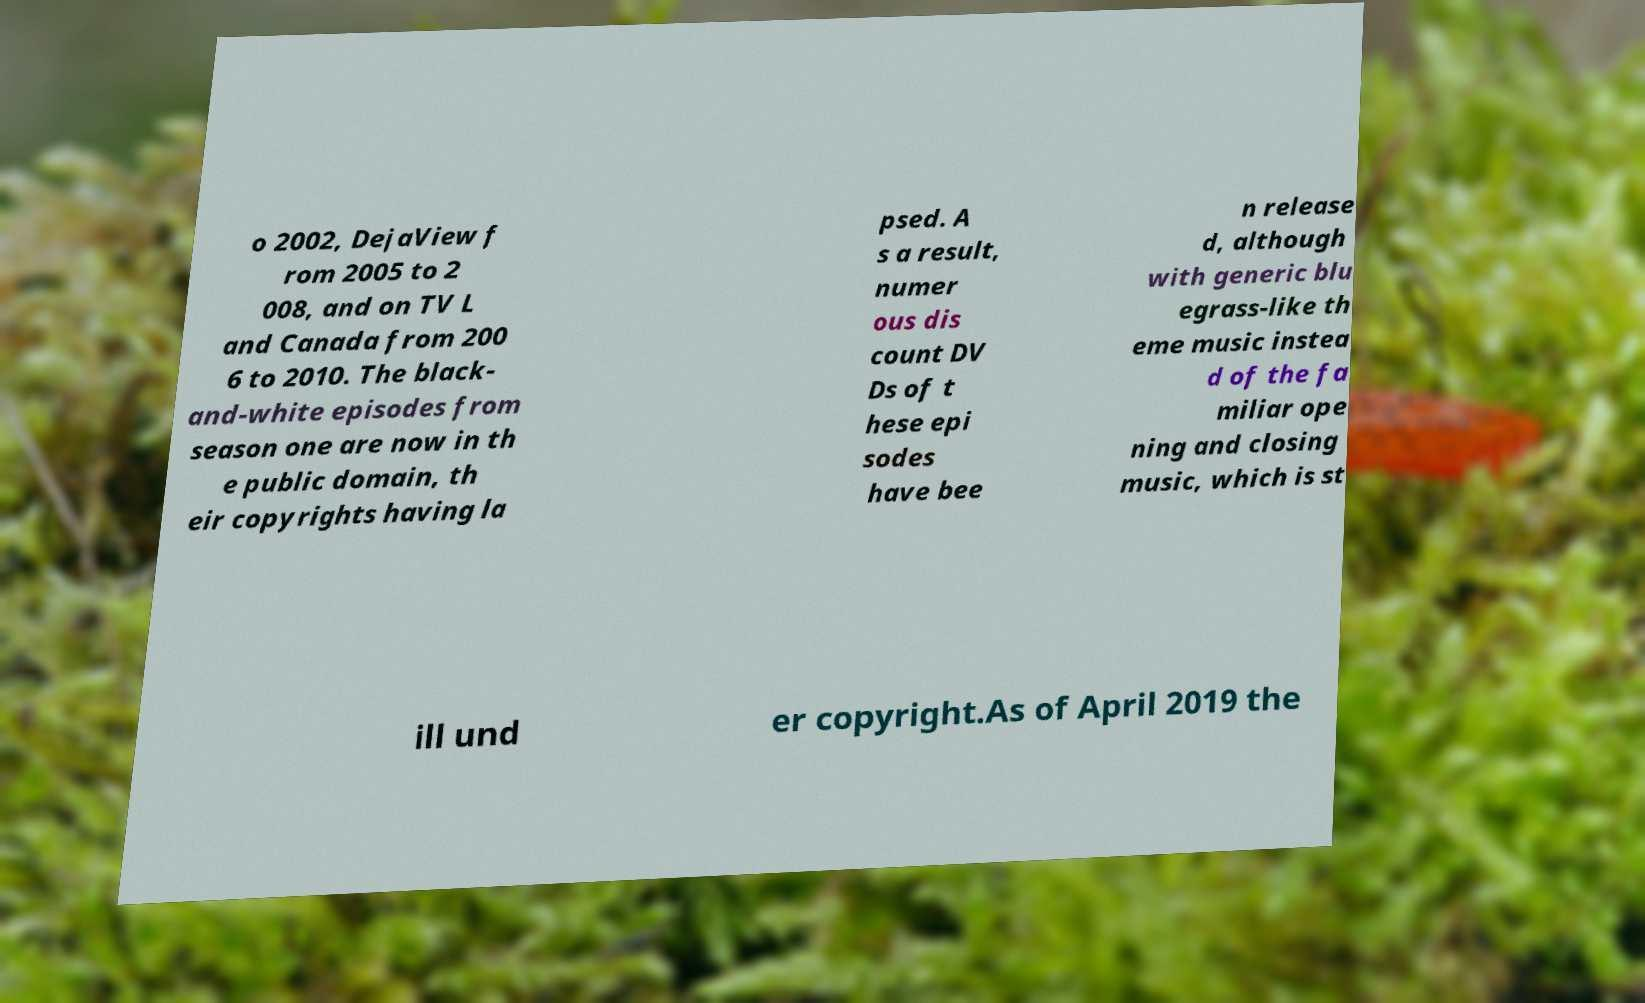Please read and relay the text visible in this image. What does it say? o 2002, DejaView f rom 2005 to 2 008, and on TV L and Canada from 200 6 to 2010. The black- and-white episodes from season one are now in th e public domain, th eir copyrights having la psed. A s a result, numer ous dis count DV Ds of t hese epi sodes have bee n release d, although with generic blu egrass-like th eme music instea d of the fa miliar ope ning and closing music, which is st ill und er copyright.As of April 2019 the 